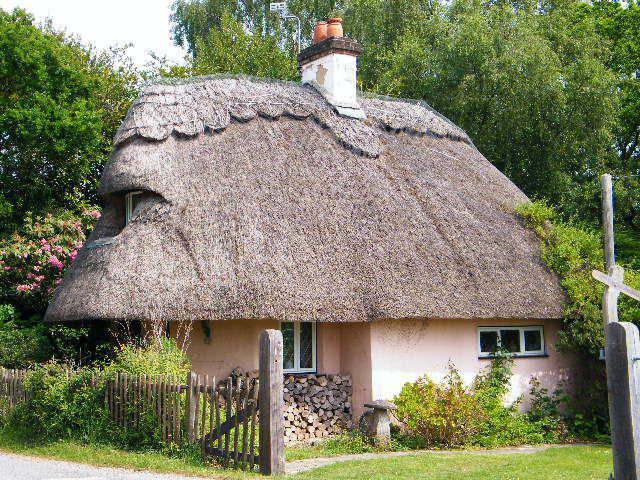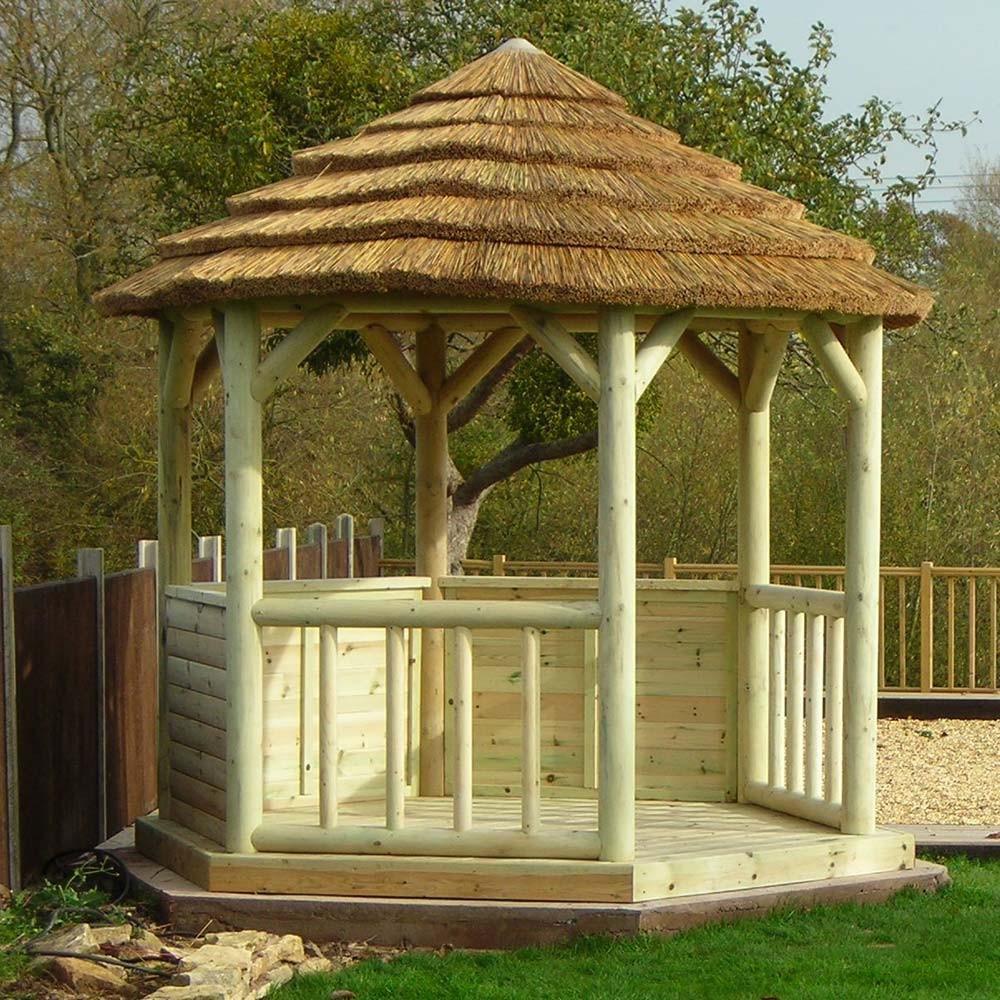The first image is the image on the left, the second image is the image on the right. Given the left and right images, does the statement "There is a cone shaped roof." hold true? Answer yes or no. Yes. The first image is the image on the left, the second image is the image on the right. For the images displayed, is the sentence "The left image shows a house with a thick gray roof covering the front and sides, topped with a chimney and a scalloped border." factually correct? Answer yes or no. Yes. 